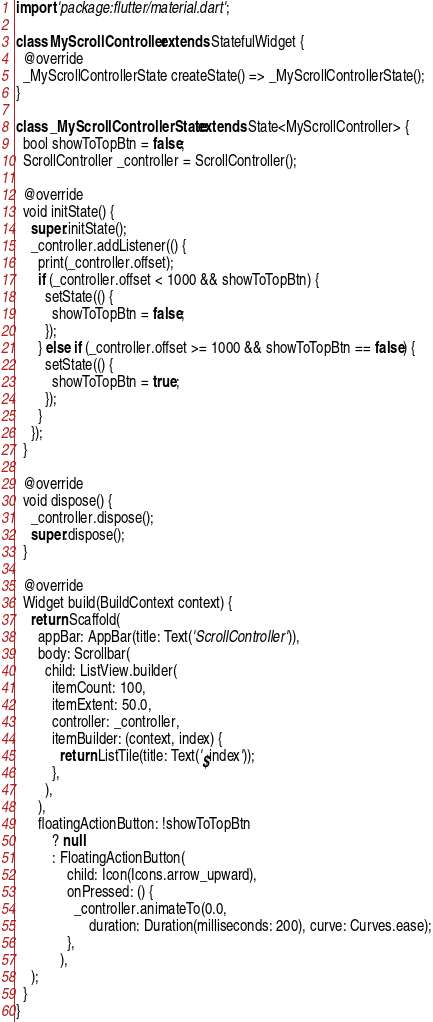Convert code to text. <code><loc_0><loc_0><loc_500><loc_500><_Dart_>import 'package:flutter/material.dart';

class MyScrollController extends StatefulWidget {
  @override
  _MyScrollControllerState createState() => _MyScrollControllerState();
}

class _MyScrollControllerState extends State<MyScrollController> {
  bool showToTopBtn = false;
  ScrollController _controller = ScrollController();

  @override
  void initState() {
    super.initState();
    _controller.addListener(() {
      print(_controller.offset);
      if (_controller.offset < 1000 && showToTopBtn) {
        setState(() {
          showToTopBtn = false;
        });
      } else if (_controller.offset >= 1000 && showToTopBtn == false) {
        setState(() {
          showToTopBtn = true;
        });
      }
    });
  }

  @override
  void dispose() {
    _controller.dispose();
    super.dispose();
  }

  @override
  Widget build(BuildContext context) {
    return Scaffold(
      appBar: AppBar(title: Text('ScrollController')),
      body: Scrollbar(
        child: ListView.builder(
          itemCount: 100,
          itemExtent: 50.0,
          controller: _controller,
          itemBuilder: (context, index) {
            return ListTile(title: Text('$index'));
          },
        ),
      ),
      floatingActionButton: !showToTopBtn
          ? null
          : FloatingActionButton(
              child: Icon(Icons.arrow_upward),
              onPressed: () {
                _controller.animateTo(0.0,
                    duration: Duration(milliseconds: 200), curve: Curves.ease);
              },
            ),
    );
  }
}
</code> 